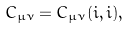<formula> <loc_0><loc_0><loc_500><loc_500>C _ { \mu \nu } = C _ { \mu \nu } ( i , i ) ,</formula> 